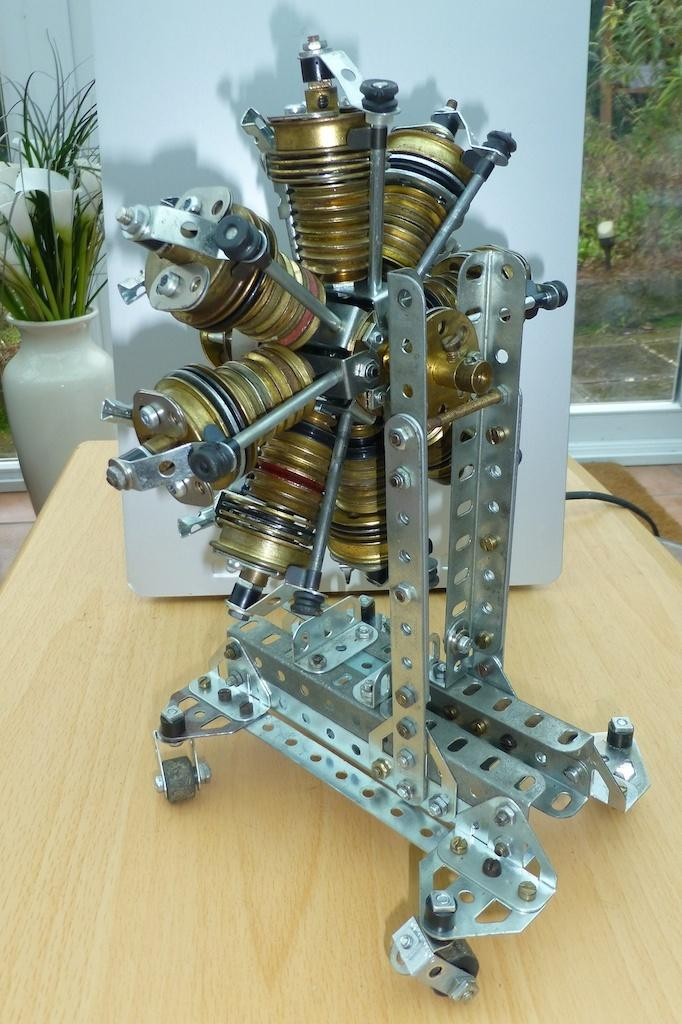What is the main object in the image? There is a machine in the image. What is the surface on which objects are placed in the image? There is a wooden table in the image. What can be seen in the background of the image? There is a flower vase and glass doors in the background of the image. What is visible through the glass doors? Trees are visible through the glass doors. What type of stem can be seen on the machine in the image? There is no stem present on the machine in the image. How does the brake function on the sink in the image? There is no sink or brake present in the image; it features a machine, a wooden table, and a background with a flower vase, glass doors, and trees. 